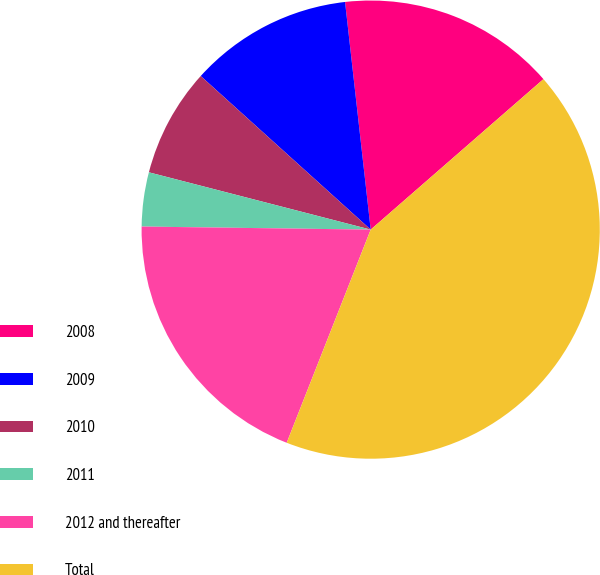Convert chart to OTSL. <chart><loc_0><loc_0><loc_500><loc_500><pie_chart><fcel>2008<fcel>2009<fcel>2010<fcel>2011<fcel>2012 and thereafter<fcel>Total<nl><fcel>15.38%<fcel>11.52%<fcel>7.67%<fcel>3.81%<fcel>19.24%<fcel>42.38%<nl></chart> 